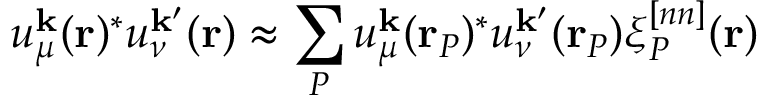<formula> <loc_0><loc_0><loc_500><loc_500>u _ { \mu } ^ { k } ( r ) ^ { * } u _ { \nu } ^ { k ^ { \prime } } ( r ) \approx \sum _ { P } u _ { \mu } ^ { k } ( r _ { P } ) ^ { * } u _ { \nu } ^ { k ^ { \prime } } ( r _ { P } ) \xi _ { P } ^ { [ n n ] } ( r )</formula> 